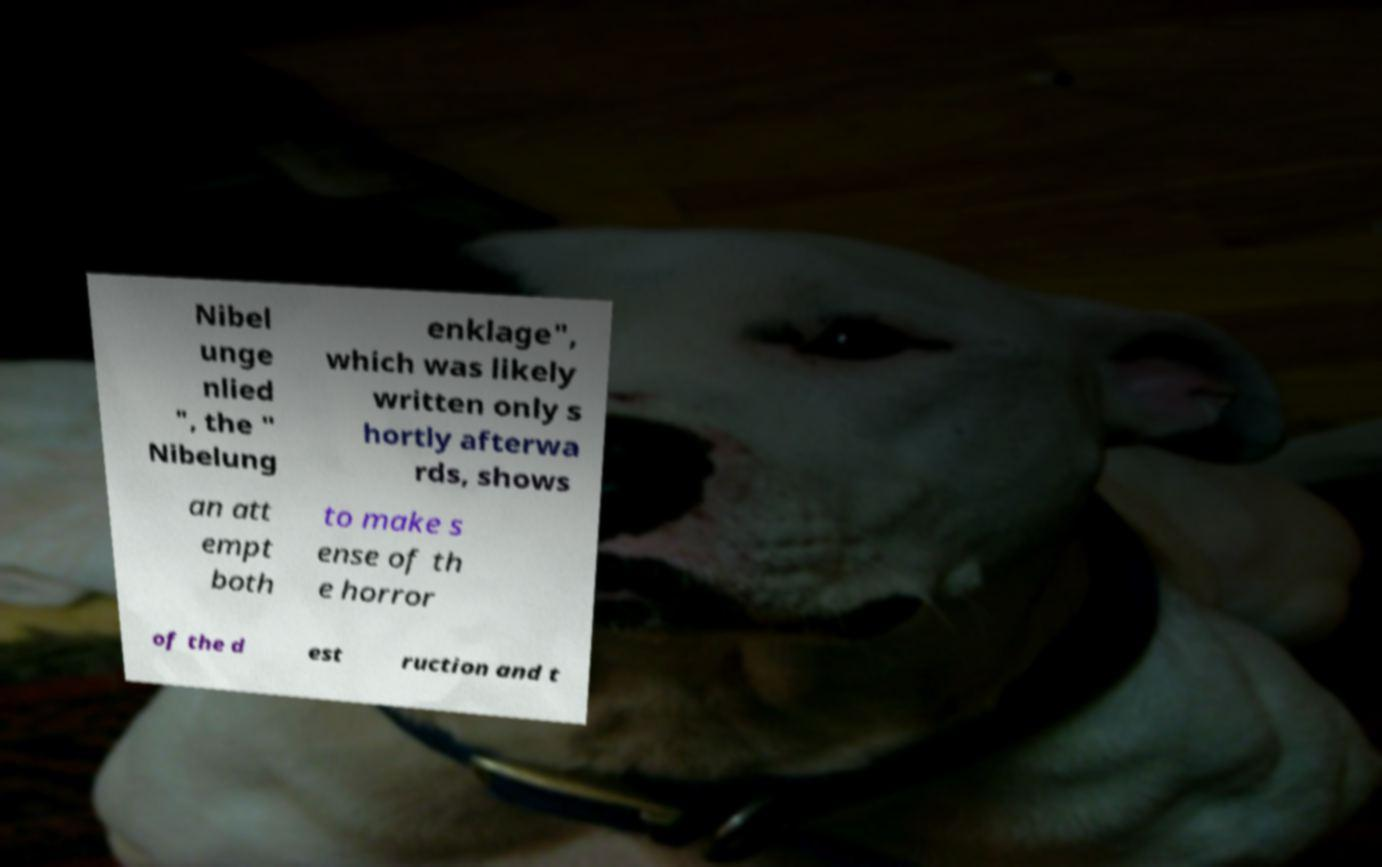Could you extract and type out the text from this image? Nibel unge nlied ", the " Nibelung enklage", which was likely written only s hortly afterwa rds, shows an att empt both to make s ense of th e horror of the d est ruction and t 